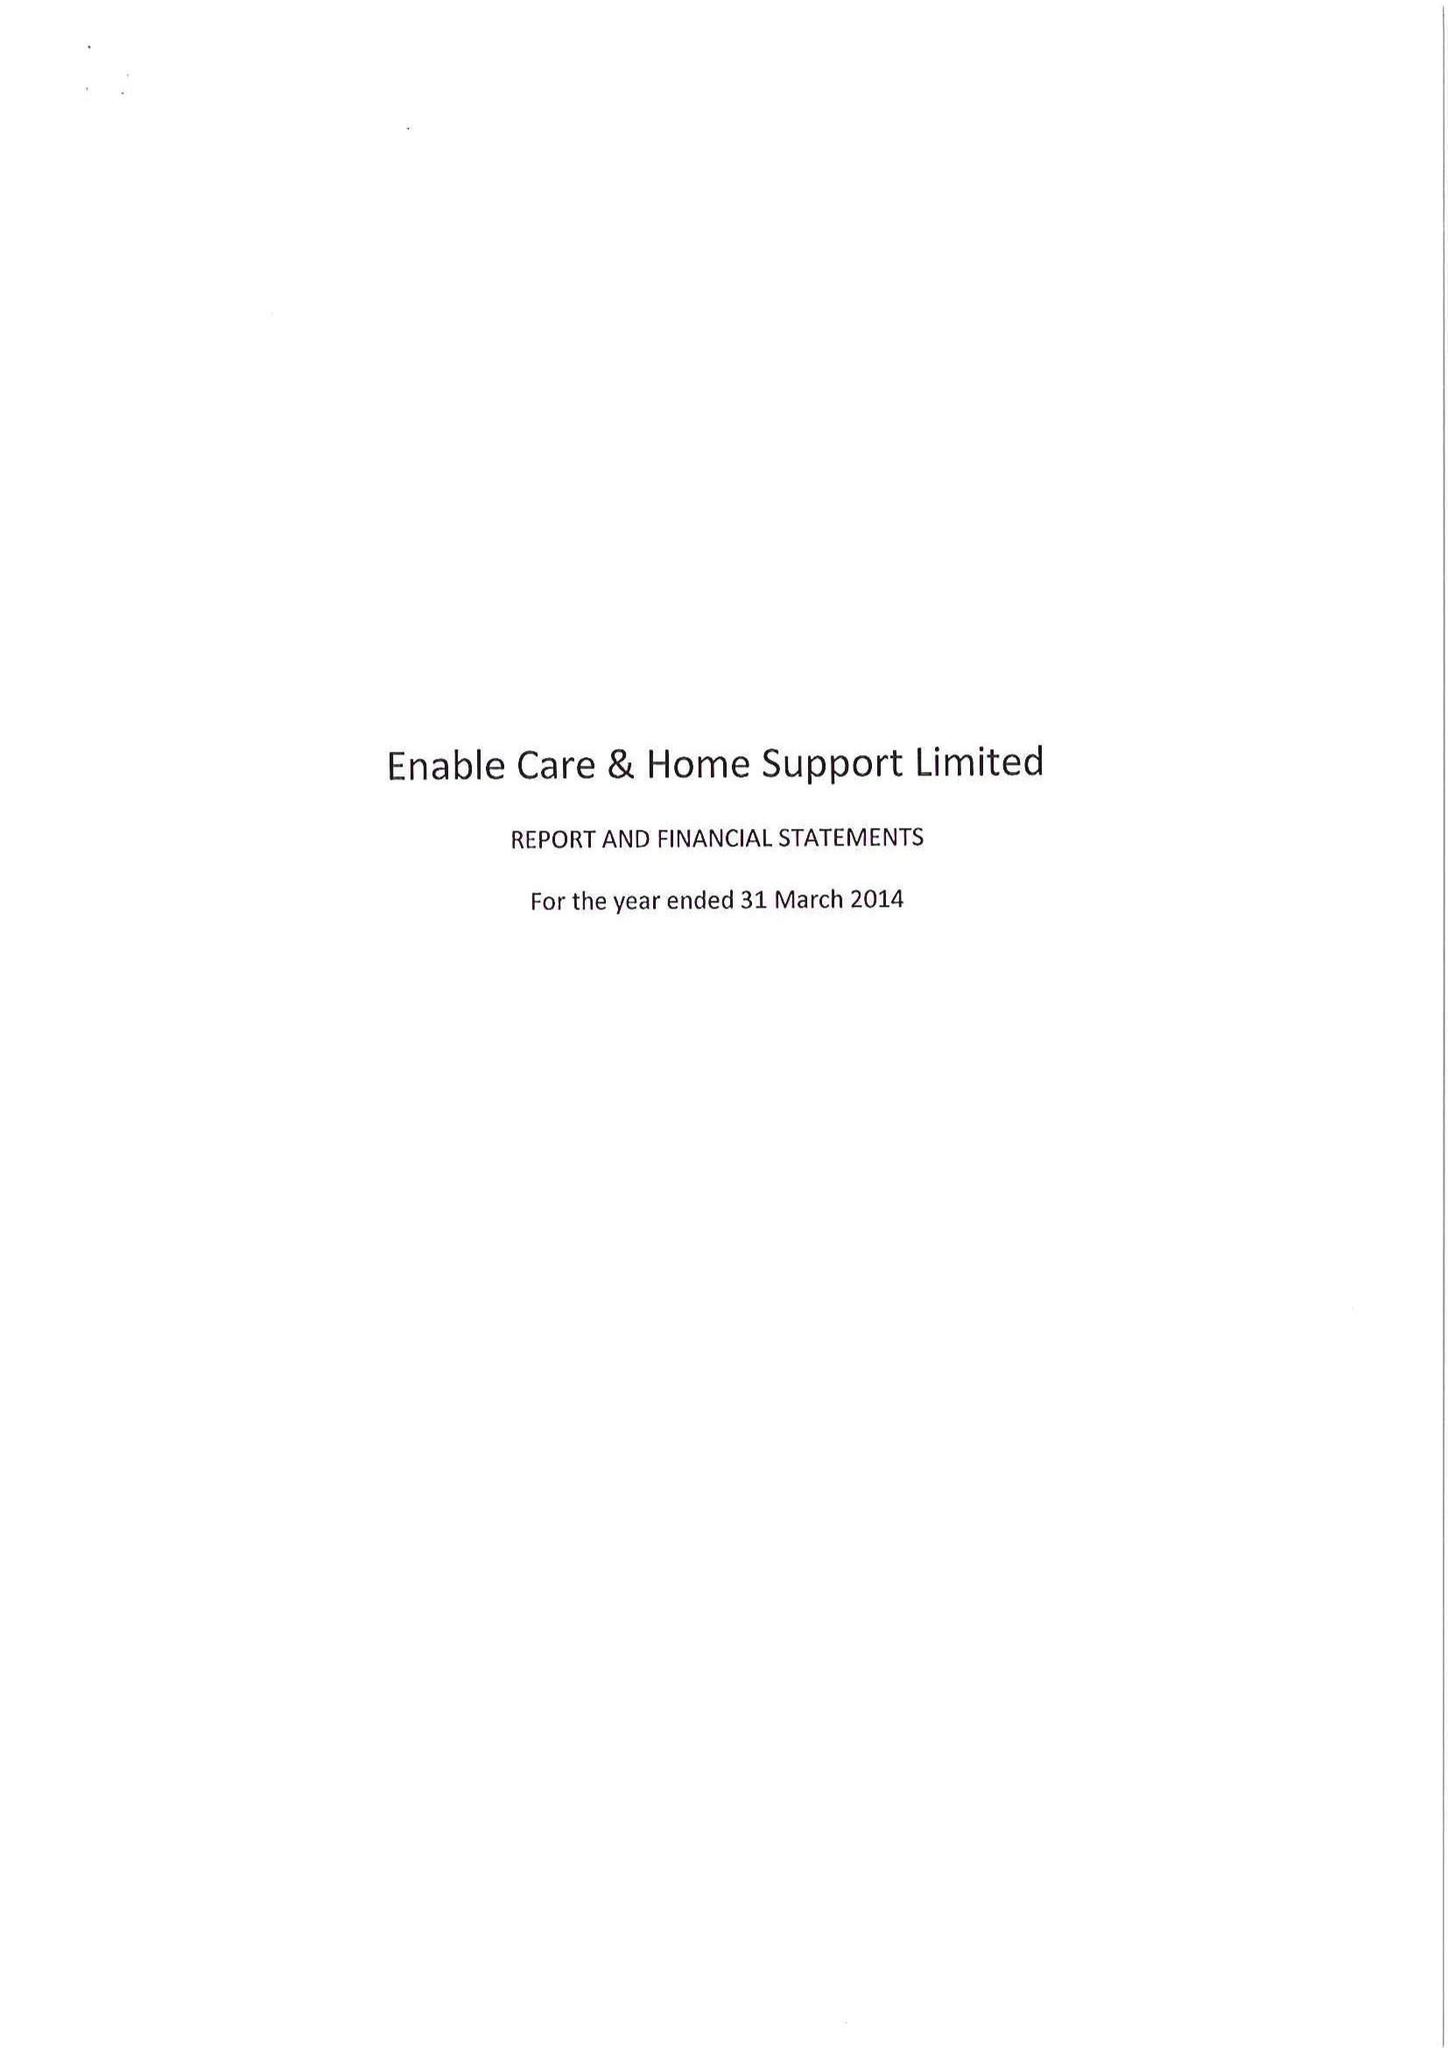What is the value for the address__street_line?
Answer the question using a single word or phrase. STENSON ROAD 